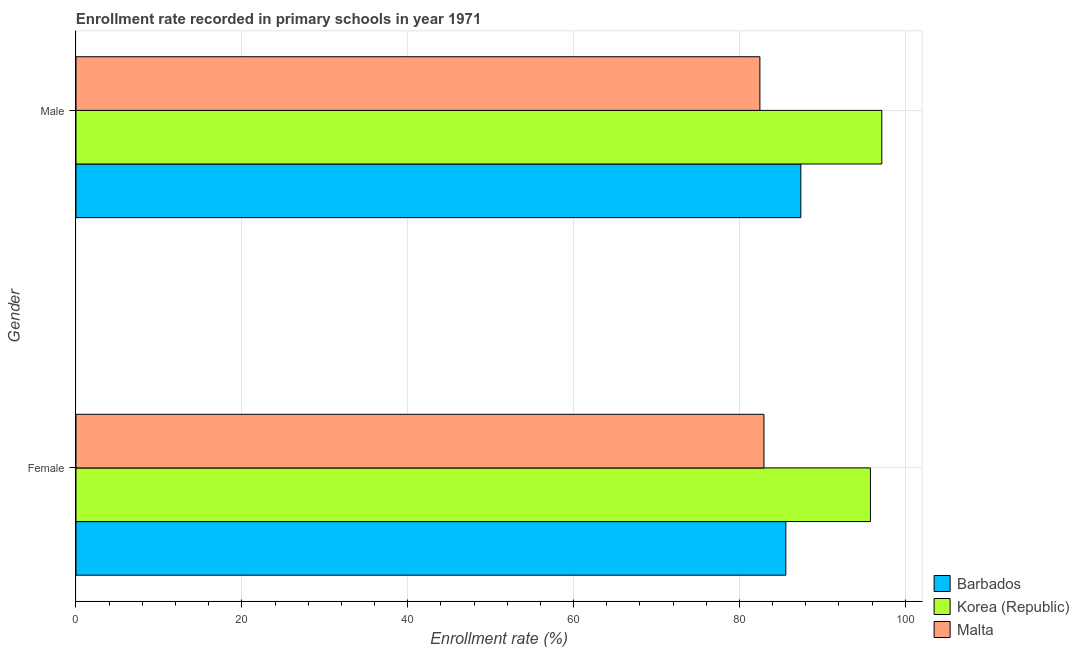How many bars are there on the 2nd tick from the top?
Your response must be concise. 3. How many bars are there on the 2nd tick from the bottom?
Make the answer very short. 3. What is the enrollment rate of male students in Korea (Republic)?
Provide a short and direct response. 97.18. Across all countries, what is the maximum enrollment rate of male students?
Give a very brief answer. 97.18. Across all countries, what is the minimum enrollment rate of male students?
Offer a very short reply. 82.47. In which country was the enrollment rate of male students maximum?
Give a very brief answer. Korea (Republic). In which country was the enrollment rate of male students minimum?
Ensure brevity in your answer.  Malta. What is the total enrollment rate of female students in the graph?
Your response must be concise. 264.37. What is the difference between the enrollment rate of male students in Malta and that in Korea (Republic)?
Your answer should be very brief. -14.7. What is the difference between the enrollment rate of male students in Malta and the enrollment rate of female students in Barbados?
Your answer should be compact. -3.13. What is the average enrollment rate of female students per country?
Your answer should be very brief. 88.12. What is the difference between the enrollment rate of female students and enrollment rate of male students in Korea (Republic)?
Give a very brief answer. -1.37. What is the ratio of the enrollment rate of female students in Korea (Republic) to that in Malta?
Give a very brief answer. 1.15. What does the 2nd bar from the top in Male represents?
Offer a very short reply. Korea (Republic). What does the 3rd bar from the bottom in Female represents?
Your response must be concise. Malta. How many bars are there?
Your answer should be compact. 6. What is the difference between two consecutive major ticks on the X-axis?
Offer a very short reply. 20. Are the values on the major ticks of X-axis written in scientific E-notation?
Your answer should be compact. No. Does the graph contain any zero values?
Offer a very short reply. No. Does the graph contain grids?
Offer a very short reply. Yes. Where does the legend appear in the graph?
Ensure brevity in your answer.  Bottom right. How many legend labels are there?
Provide a succinct answer. 3. How are the legend labels stacked?
Your answer should be compact. Vertical. What is the title of the graph?
Your answer should be compact. Enrollment rate recorded in primary schools in year 1971. Does "Antigua and Barbuda" appear as one of the legend labels in the graph?
Your response must be concise. No. What is the label or title of the X-axis?
Give a very brief answer. Enrollment rate (%). What is the label or title of the Y-axis?
Ensure brevity in your answer.  Gender. What is the Enrollment rate (%) in Barbados in Female?
Your answer should be very brief. 85.6. What is the Enrollment rate (%) of Korea (Republic) in Female?
Keep it short and to the point. 95.8. What is the Enrollment rate (%) in Malta in Female?
Offer a terse response. 82.96. What is the Enrollment rate (%) of Barbados in Male?
Your answer should be very brief. 87.41. What is the Enrollment rate (%) of Korea (Republic) in Male?
Provide a succinct answer. 97.18. What is the Enrollment rate (%) in Malta in Male?
Offer a terse response. 82.47. Across all Gender, what is the maximum Enrollment rate (%) of Barbados?
Offer a very short reply. 87.41. Across all Gender, what is the maximum Enrollment rate (%) in Korea (Republic)?
Offer a terse response. 97.18. Across all Gender, what is the maximum Enrollment rate (%) in Malta?
Give a very brief answer. 82.96. Across all Gender, what is the minimum Enrollment rate (%) of Barbados?
Offer a very short reply. 85.6. Across all Gender, what is the minimum Enrollment rate (%) in Korea (Republic)?
Provide a succinct answer. 95.8. Across all Gender, what is the minimum Enrollment rate (%) of Malta?
Provide a short and direct response. 82.47. What is the total Enrollment rate (%) of Barbados in the graph?
Offer a very short reply. 173.01. What is the total Enrollment rate (%) in Korea (Republic) in the graph?
Keep it short and to the point. 192.98. What is the total Enrollment rate (%) of Malta in the graph?
Give a very brief answer. 165.44. What is the difference between the Enrollment rate (%) of Barbados in Female and that in Male?
Your response must be concise. -1.81. What is the difference between the Enrollment rate (%) of Korea (Republic) in Female and that in Male?
Your response must be concise. -1.37. What is the difference between the Enrollment rate (%) of Malta in Female and that in Male?
Your answer should be very brief. 0.49. What is the difference between the Enrollment rate (%) in Barbados in Female and the Enrollment rate (%) in Korea (Republic) in Male?
Give a very brief answer. -11.58. What is the difference between the Enrollment rate (%) of Barbados in Female and the Enrollment rate (%) of Malta in Male?
Your response must be concise. 3.13. What is the difference between the Enrollment rate (%) of Korea (Republic) in Female and the Enrollment rate (%) of Malta in Male?
Give a very brief answer. 13.33. What is the average Enrollment rate (%) of Barbados per Gender?
Offer a terse response. 86.51. What is the average Enrollment rate (%) of Korea (Republic) per Gender?
Provide a succinct answer. 96.49. What is the average Enrollment rate (%) of Malta per Gender?
Make the answer very short. 82.72. What is the difference between the Enrollment rate (%) of Barbados and Enrollment rate (%) of Korea (Republic) in Female?
Ensure brevity in your answer.  -10.2. What is the difference between the Enrollment rate (%) of Barbados and Enrollment rate (%) of Malta in Female?
Offer a very short reply. 2.64. What is the difference between the Enrollment rate (%) in Korea (Republic) and Enrollment rate (%) in Malta in Female?
Provide a succinct answer. 12.84. What is the difference between the Enrollment rate (%) of Barbados and Enrollment rate (%) of Korea (Republic) in Male?
Your answer should be compact. -9.76. What is the difference between the Enrollment rate (%) of Barbados and Enrollment rate (%) of Malta in Male?
Make the answer very short. 4.94. What is the difference between the Enrollment rate (%) in Korea (Republic) and Enrollment rate (%) in Malta in Male?
Make the answer very short. 14.7. What is the ratio of the Enrollment rate (%) of Barbados in Female to that in Male?
Keep it short and to the point. 0.98. What is the ratio of the Enrollment rate (%) in Korea (Republic) in Female to that in Male?
Provide a short and direct response. 0.99. What is the ratio of the Enrollment rate (%) in Malta in Female to that in Male?
Provide a short and direct response. 1.01. What is the difference between the highest and the second highest Enrollment rate (%) of Barbados?
Your response must be concise. 1.81. What is the difference between the highest and the second highest Enrollment rate (%) in Korea (Republic)?
Provide a short and direct response. 1.37. What is the difference between the highest and the second highest Enrollment rate (%) of Malta?
Keep it short and to the point. 0.49. What is the difference between the highest and the lowest Enrollment rate (%) in Barbados?
Your response must be concise. 1.81. What is the difference between the highest and the lowest Enrollment rate (%) of Korea (Republic)?
Provide a short and direct response. 1.37. What is the difference between the highest and the lowest Enrollment rate (%) of Malta?
Your response must be concise. 0.49. 